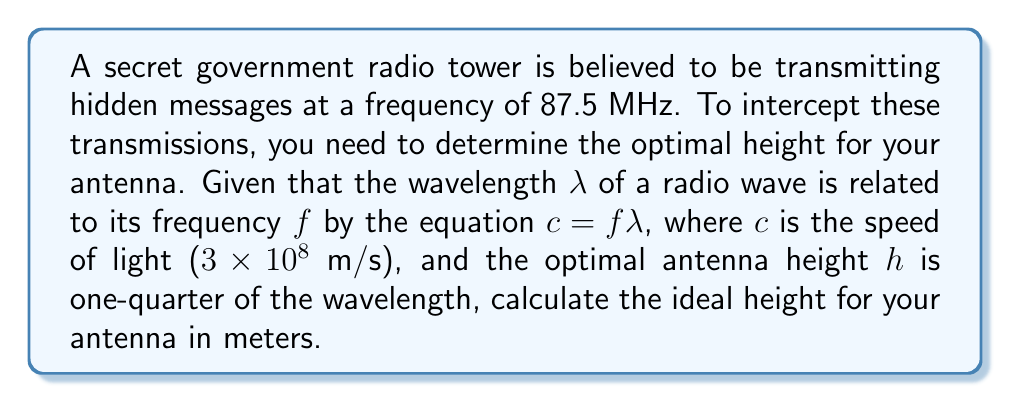Give your solution to this math problem. To solve this problem, we'll follow these steps:

1. Calculate the wavelength of the radio waves:
   We know that $c = f\lambda$, where:
   $c = 3 \times 10^8$ m/s (speed of light)
   $f = 87.5$ MHz = $87.5 \times 10^6$ Hz

   Rearranging the equation: $\lambda = \frac{c}{f}$

   $$\lambda = \frac{3 \times 10^8}{87.5 \times 10^6} = \frac{300,000,000}{87,500,000} = 3.4285714$$

   So, $\lambda \approx 3.4286$ meters

2. Calculate the optimal antenna height:
   The optimal height h is one-quarter of the wavelength:

   $$h = \frac{1}{4} \lambda$$

   $$h = \frac{1}{4} \times 3.4286 = 0.85715$$

Therefore, the optimal antenna height is approximately 0.8571 meters.
Answer: The optimal antenna height is approximately 0.8571 meters. 